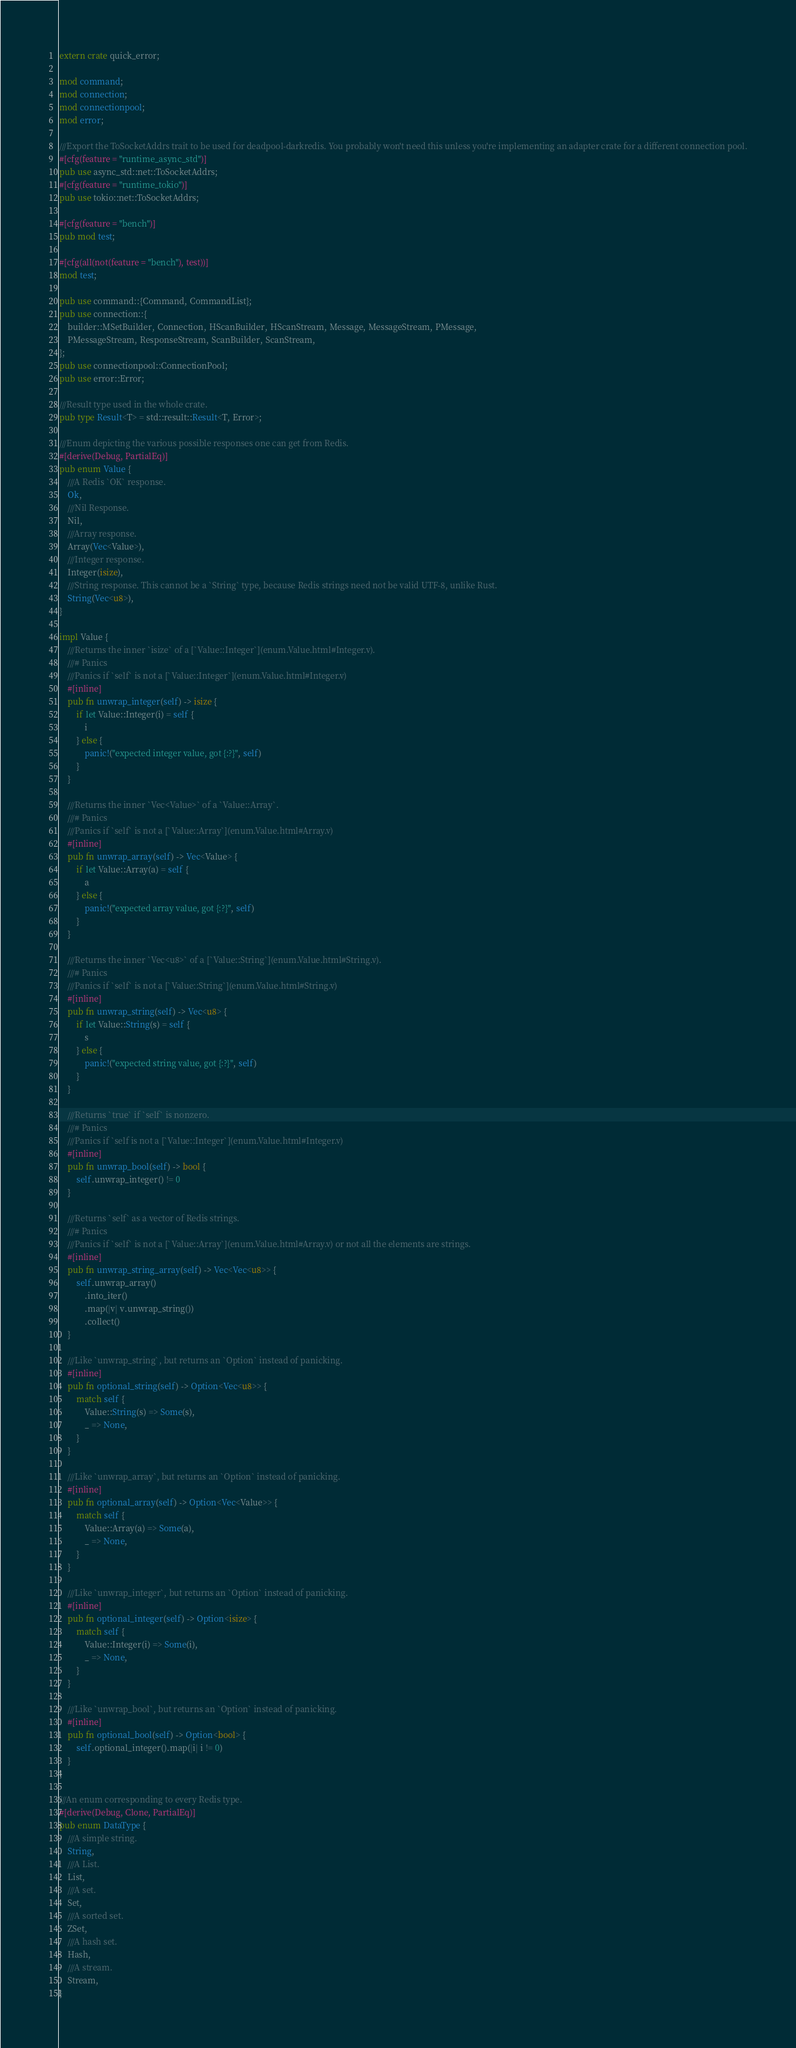Convert code to text. <code><loc_0><loc_0><loc_500><loc_500><_Rust_>extern crate quick_error;

mod command;
mod connection;
mod connectionpool;
mod error;

///Export the ToSocketAddrs trait to be used for deadpool-darkredis. You probably won't need this unless you're implementing an adapter crate for a different connection pool.
#[cfg(feature = "runtime_async_std")]
pub use async_std::net::ToSocketAddrs;
#[cfg(feature = "runtime_tokio")]
pub use tokio::net::ToSocketAddrs;

#[cfg(feature = "bench")]
pub mod test;

#[cfg(all(not(feature = "bench"), test))]
mod test;

pub use command::{Command, CommandList};
pub use connection::{
    builder::MSetBuilder, Connection, HScanBuilder, HScanStream, Message, MessageStream, PMessage,
    PMessageStream, ResponseStream, ScanBuilder, ScanStream,
};
pub use connectionpool::ConnectionPool;
pub use error::Error;

///Result type used in the whole crate.
pub type Result<T> = std::result::Result<T, Error>;

///Enum depicting the various possible responses one can get from Redis.
#[derive(Debug, PartialEq)]
pub enum Value {
    ///A Redis `OK` response.
    Ok,
    ///Nil Response.
    Nil,
    ///Array response.
    Array(Vec<Value>),
    ///Integer response.
    Integer(isize),
    ///String response. This cannot be a `String` type, because Redis strings need not be valid UTF-8, unlike Rust.
    String(Vec<u8>),
}

impl Value {
    ///Returns the inner `isize` of a [`Value::Integer`](enum.Value.html#Integer.v).
    ///# Panics
    ///Panics if `self` is not a [`Value::Integer`](enum.Value.html#Integer.v)
    #[inline]
    pub fn unwrap_integer(self) -> isize {
        if let Value::Integer(i) = self {
            i
        } else {
            panic!("expected integer value, got {:?}", self)
        }
    }

    ///Returns the inner `Vec<Value>` of a `Value::Array`.
    ///# Panics
    ///Panics if `self` is not a [`Value::Array`](enum.Value.html#Array.v)
    #[inline]
    pub fn unwrap_array(self) -> Vec<Value> {
        if let Value::Array(a) = self {
            a
        } else {
            panic!("expected array value, got {:?}", self)
        }
    }

    ///Returns the inner `Vec<u8>` of a [`Value::String`](enum.Value.html#String.v).
    ///# Panics
    ///Panics if `self` is not a [`Value::String`](enum.Value.html#String.v)
    #[inline]
    pub fn unwrap_string(self) -> Vec<u8> {
        if let Value::String(s) = self {
            s
        } else {
            panic!("expected string value, got {:?}", self)
        }
    }

    ///Returns `true` if `self` is nonzero.
    ///# Panics
    ///Panics if `self is not a [`Value::Integer`](enum.Value.html#Integer.v)
    #[inline]
    pub fn unwrap_bool(self) -> bool {
        self.unwrap_integer() != 0
    }

    ///Returns `self` as a vector of Redis strings.
    ///# Panics
    ///Panics if `self` is not a [`Value::Array`](enum.Value.html#Array.v) or not all the elements are strings.
    #[inline]
    pub fn unwrap_string_array(self) -> Vec<Vec<u8>> {
        self.unwrap_array()
            .into_iter()
            .map(|v| v.unwrap_string())
            .collect()
    }

    ///Like `unwrap_string`, but returns an `Option` instead of panicking.
    #[inline]
    pub fn optional_string(self) -> Option<Vec<u8>> {
        match self {
            Value::String(s) => Some(s),
            _ => None,
        }
    }

    ///Like `unwrap_array`, but returns an `Option` instead of panicking.
    #[inline]
    pub fn optional_array(self) -> Option<Vec<Value>> {
        match self {
            Value::Array(a) => Some(a),
            _ => None,
        }
    }

    ///Like `unwrap_integer`, but returns an `Option` instead of panicking.
    #[inline]
    pub fn optional_integer(self) -> Option<isize> {
        match self {
            Value::Integer(i) => Some(i),
            _ => None,
        }
    }

    ///Like `unwrap_bool`, but returns an `Option` instead of panicking.
    #[inline]
    pub fn optional_bool(self) -> Option<bool> {
        self.optional_integer().map(|i| i != 0)
    }
}

///An enum corresponding to every Redis type.
#[derive(Debug, Clone, PartialEq)]
pub enum DataType {
    ///A simple string.
    String,
    ///A List.
    List,
    ///A set.
    Set,
    ///A sorted set.
    ZSet,
    ///A hash set.
    Hash,
    ///A stream.
    Stream,
}
</code> 